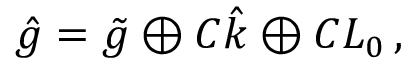<formula> <loc_0><loc_0><loc_500><loc_500>\hat { g } = \tilde { g } \oplus C \hat { k } \oplus C L _ { 0 } \, ,</formula> 